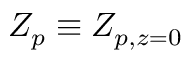Convert formula to latex. <formula><loc_0><loc_0><loc_500><loc_500>Z _ { p } \equiv Z _ { p , z = 0 }</formula> 